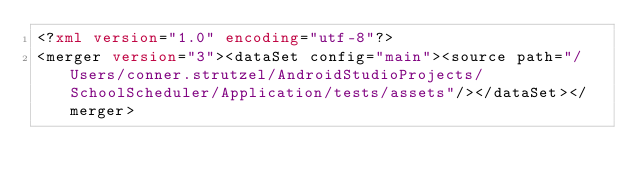Convert code to text. <code><loc_0><loc_0><loc_500><loc_500><_XML_><?xml version="1.0" encoding="utf-8"?>
<merger version="3"><dataSet config="main"><source path="/Users/conner.strutzel/AndroidStudioProjects/SchoolScheduler/Application/tests/assets"/></dataSet></merger></code> 